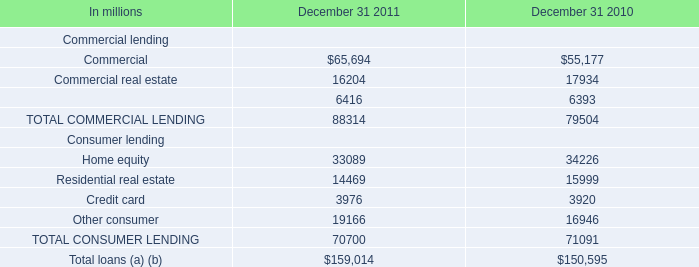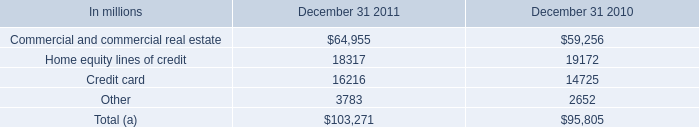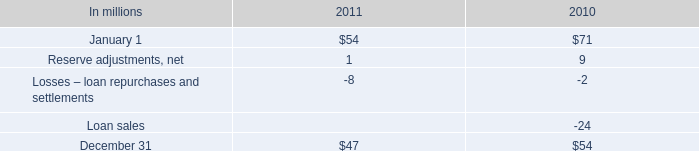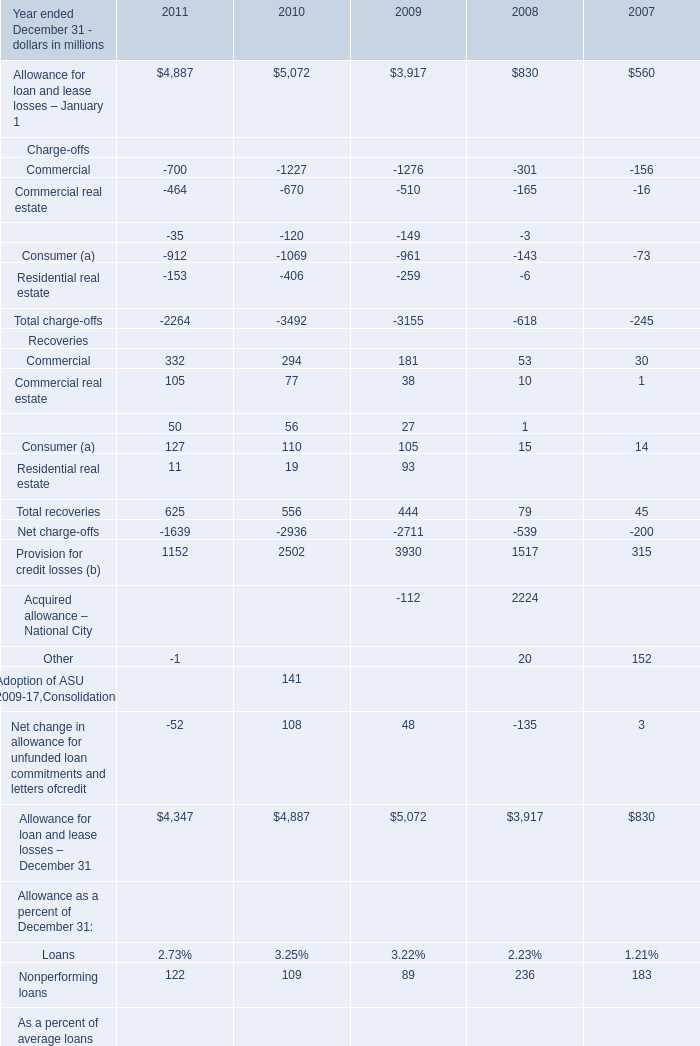in 2011 what was the percentage change in the commercial mortgage recourse obligations . 
Computations: ((47 - 54) / 54)
Answer: -0.12963. 